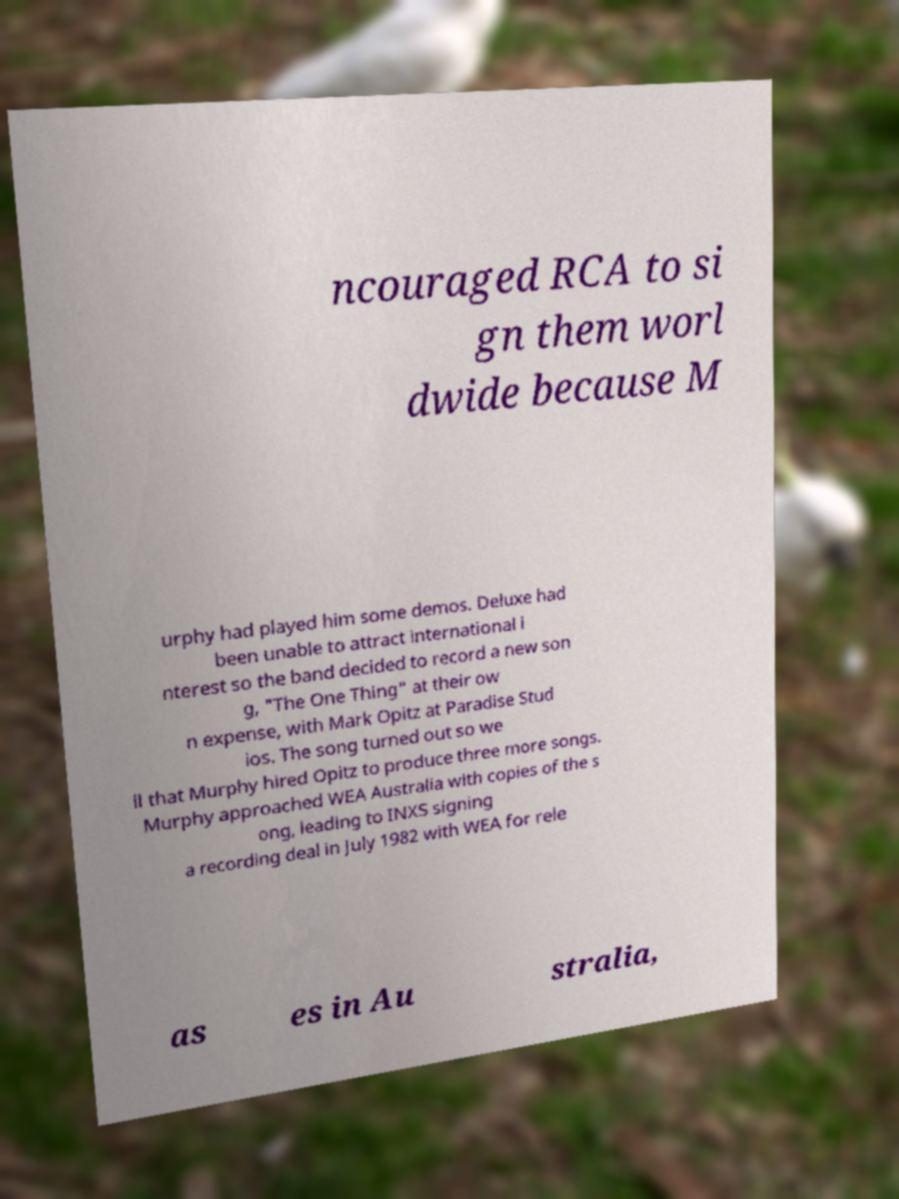For documentation purposes, I need the text within this image transcribed. Could you provide that? ncouraged RCA to si gn them worl dwide because M urphy had played him some demos. Deluxe had been unable to attract international i nterest so the band decided to record a new son g, "The One Thing" at their ow n expense, with Mark Opitz at Paradise Stud ios. The song turned out so we ll that Murphy hired Opitz to produce three more songs. Murphy approached WEA Australia with copies of the s ong, leading to INXS signing a recording deal in July 1982 with WEA for rele as es in Au stralia, 